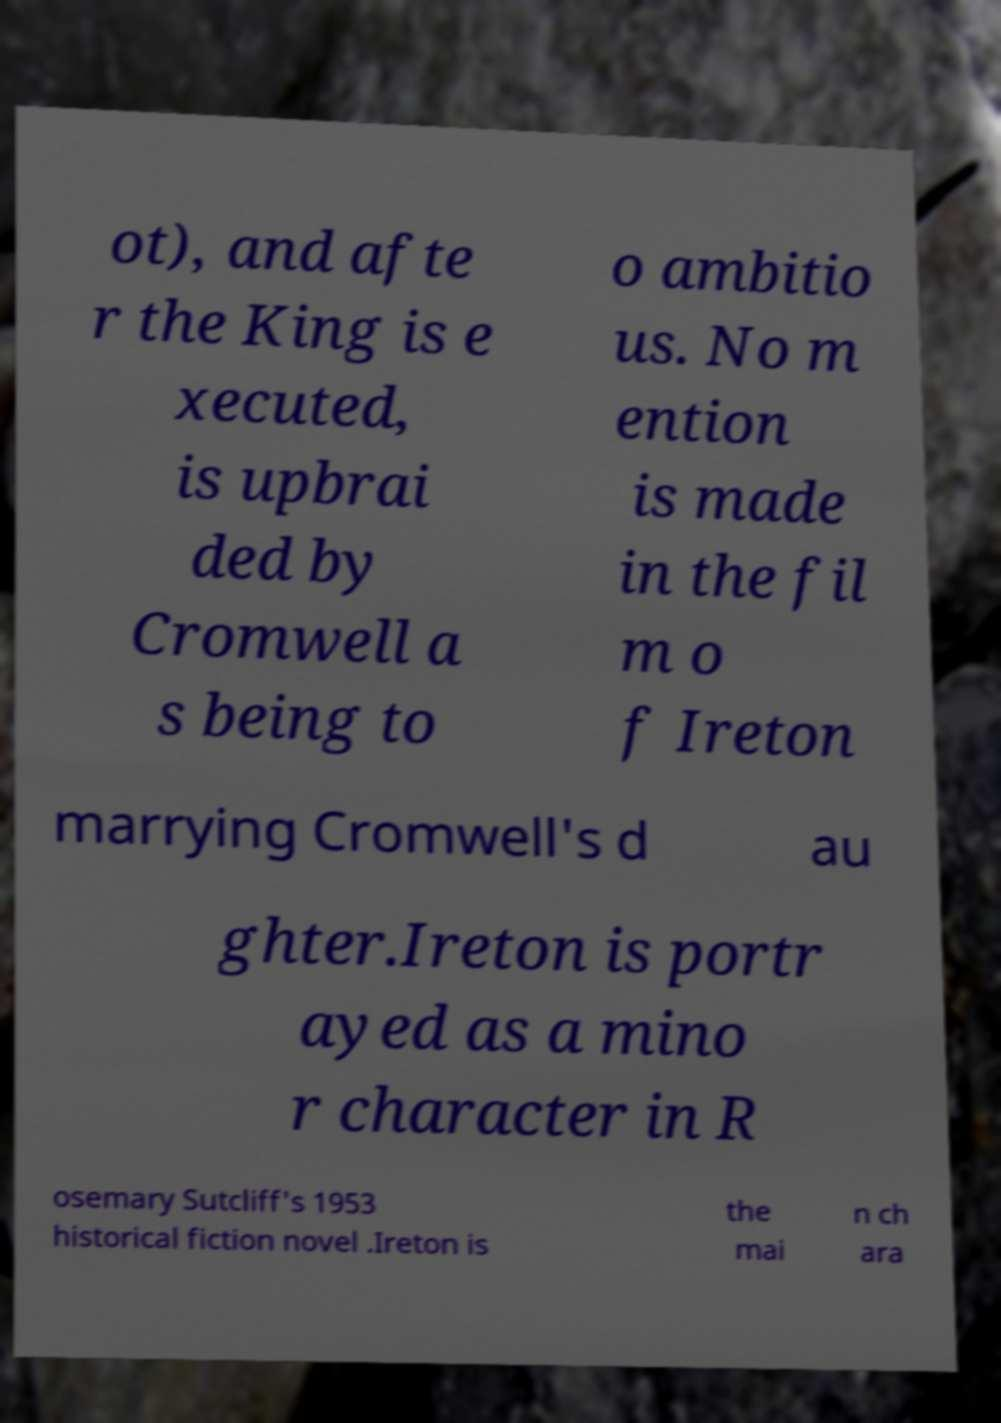There's text embedded in this image that I need extracted. Can you transcribe it verbatim? ot), and afte r the King is e xecuted, is upbrai ded by Cromwell a s being to o ambitio us. No m ention is made in the fil m o f Ireton marrying Cromwell's d au ghter.Ireton is portr ayed as a mino r character in R osemary Sutcliff's 1953 historical fiction novel .Ireton is the mai n ch ara 